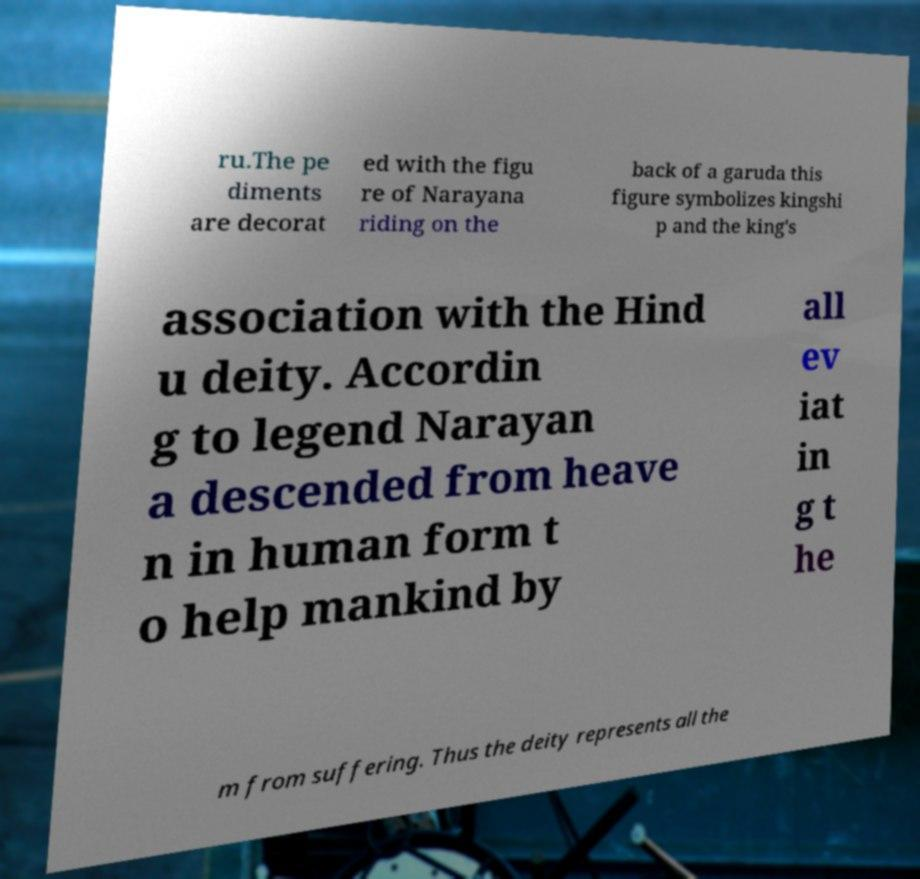For documentation purposes, I need the text within this image transcribed. Could you provide that? ru.The pe diments are decorat ed with the figu re of Narayana riding on the back of a garuda this figure symbolizes kingshi p and the king's association with the Hind u deity. Accordin g to legend Narayan a descended from heave n in human form t o help mankind by all ev iat in g t he m from suffering. Thus the deity represents all the 